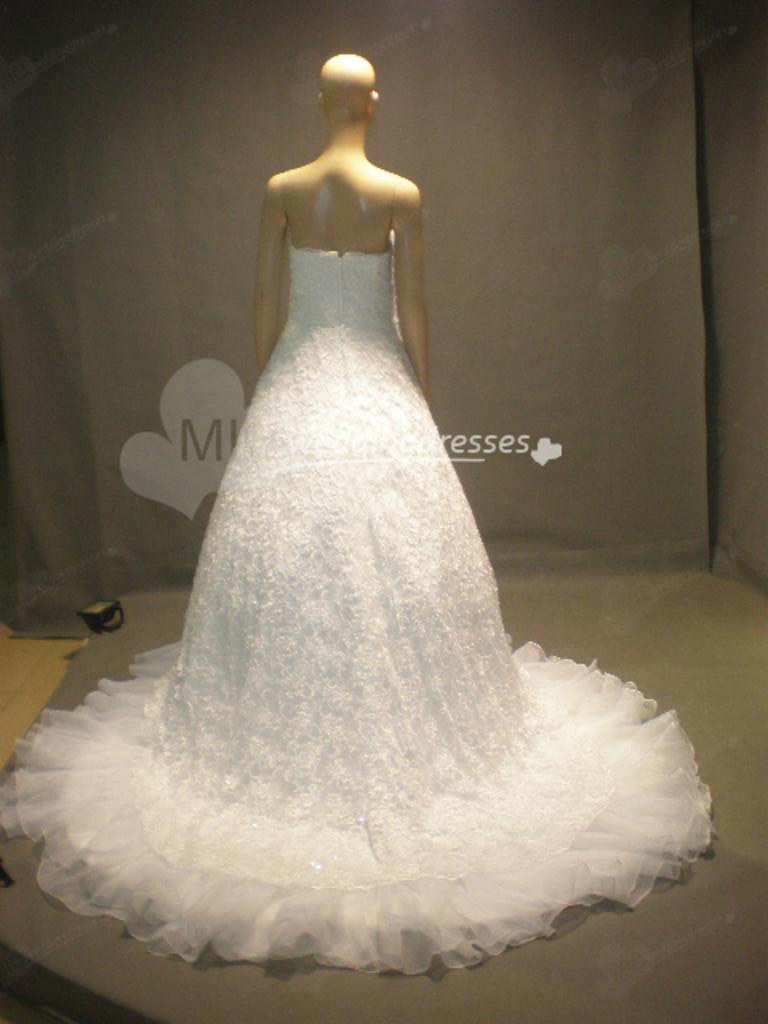Describe this image in one or two sentences. In this image I can see the mannequin with the white color dress. I can see the ash color background. 